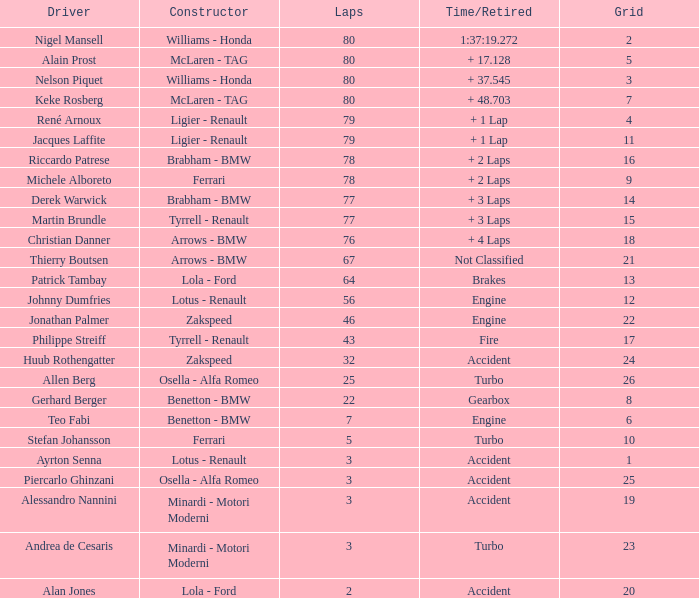What is the time/retired for thierry boutsen? Not Classified. 